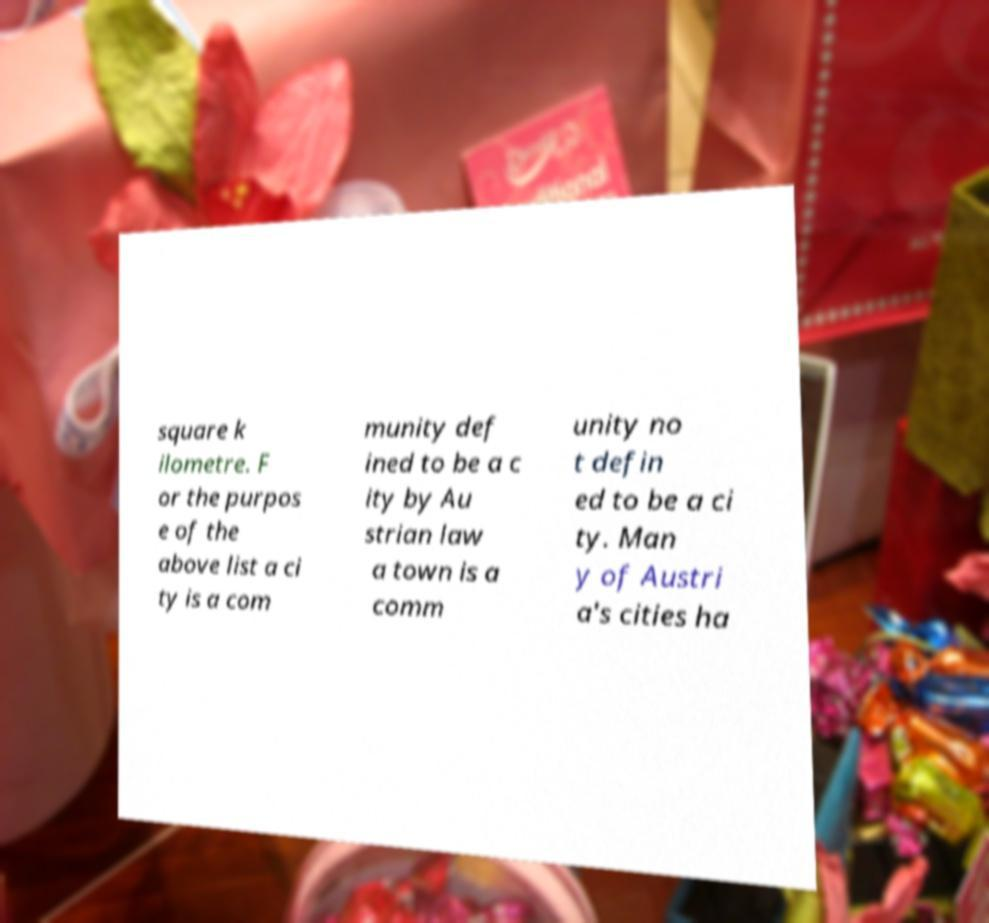Can you read and provide the text displayed in the image?This photo seems to have some interesting text. Can you extract and type it out for me? square k ilometre. F or the purpos e of the above list a ci ty is a com munity def ined to be a c ity by Au strian law a town is a comm unity no t defin ed to be a ci ty. Man y of Austri a's cities ha 